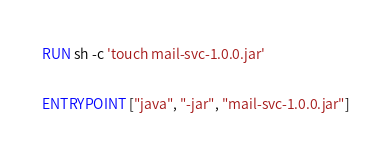Convert code to text. <code><loc_0><loc_0><loc_500><loc_500><_Dockerfile_>RUN sh -c 'touch mail-svc-1.0.0.jar'

ENTRYPOINT ["java", "-jar", "mail-svc-1.0.0.jar"]</code> 